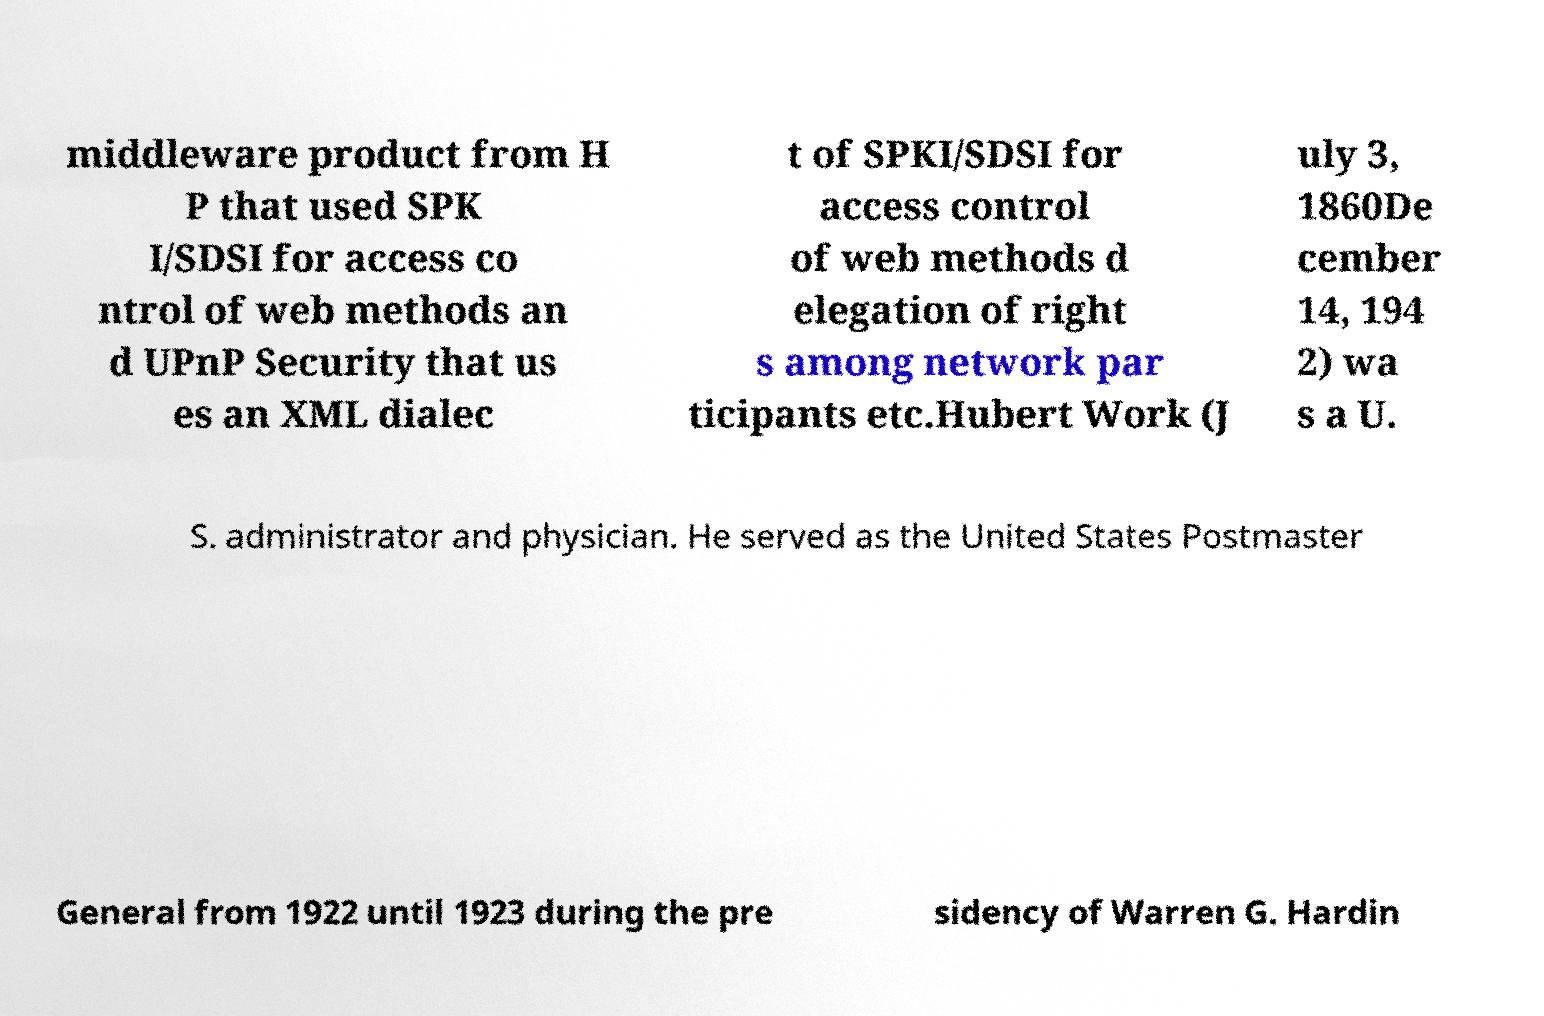Can you accurately transcribe the text from the provided image for me? middleware product from H P that used SPK I/SDSI for access co ntrol of web methods an d UPnP Security that us es an XML dialec t of SPKI/SDSI for access control of web methods d elegation of right s among network par ticipants etc.Hubert Work (J uly 3, 1860De cember 14, 194 2) wa s a U. S. administrator and physician. He served as the United States Postmaster General from 1922 until 1923 during the pre sidency of Warren G. Hardin 